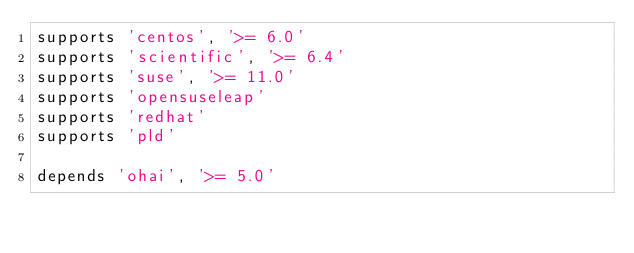Convert code to text. <code><loc_0><loc_0><loc_500><loc_500><_Ruby_>supports 'centos', '>= 6.0'
supports 'scientific', '>= 6.4'
supports 'suse', '>= 11.0'
supports 'opensuseleap'
supports 'redhat'
supports 'pld'

depends 'ohai', '>= 5.0'
</code> 